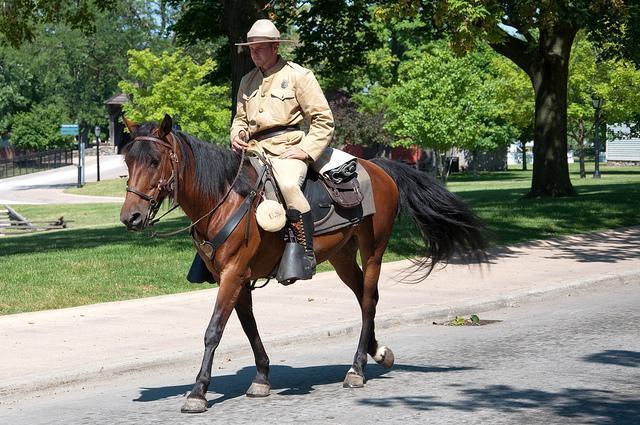How many mugs have a spoon resting inside them?
Give a very brief answer. 0. 